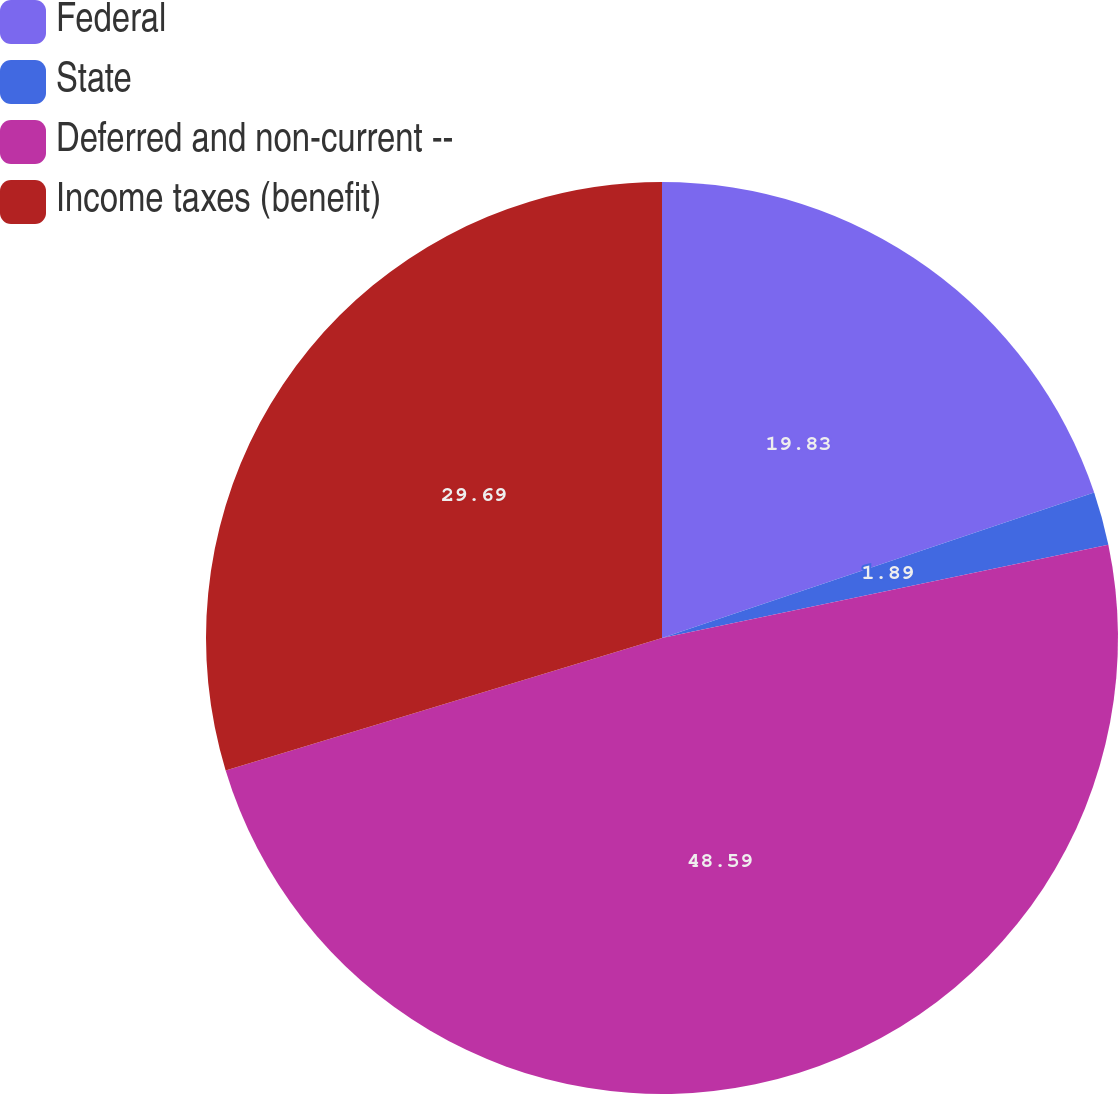Convert chart. <chart><loc_0><loc_0><loc_500><loc_500><pie_chart><fcel>Federal<fcel>State<fcel>Deferred and non-current --<fcel>Income taxes (benefit)<nl><fcel>19.83%<fcel>1.89%<fcel>48.59%<fcel>29.69%<nl></chart> 